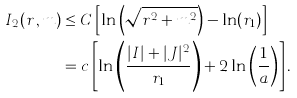Convert formula to latex. <formula><loc_0><loc_0><loc_500><loc_500>I _ { 2 } ( r \, , m ) & \leq C \left [ \ln \left ( \sqrt { r ^ { 2 } + m ^ { 2 } } \right ) - \ln ( r _ { 1 } ) \right ] \\ & = c \left [ \ln \left ( \frac { | I | + | J | ^ { 2 } } { r _ { 1 } } \right ) + 2 \ln \left ( \frac { 1 } { a } \right ) \right ] .</formula> 